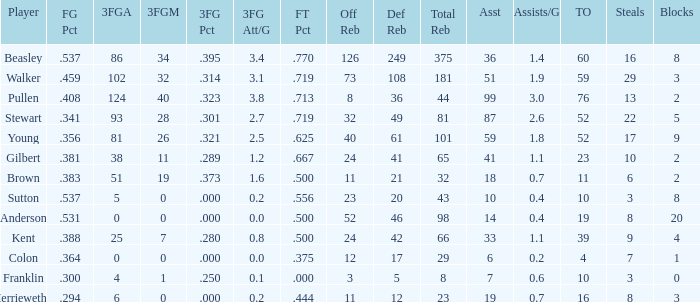What is the total number of offensive rebounds for players with more than 124 3-point attempts? 0.0. 